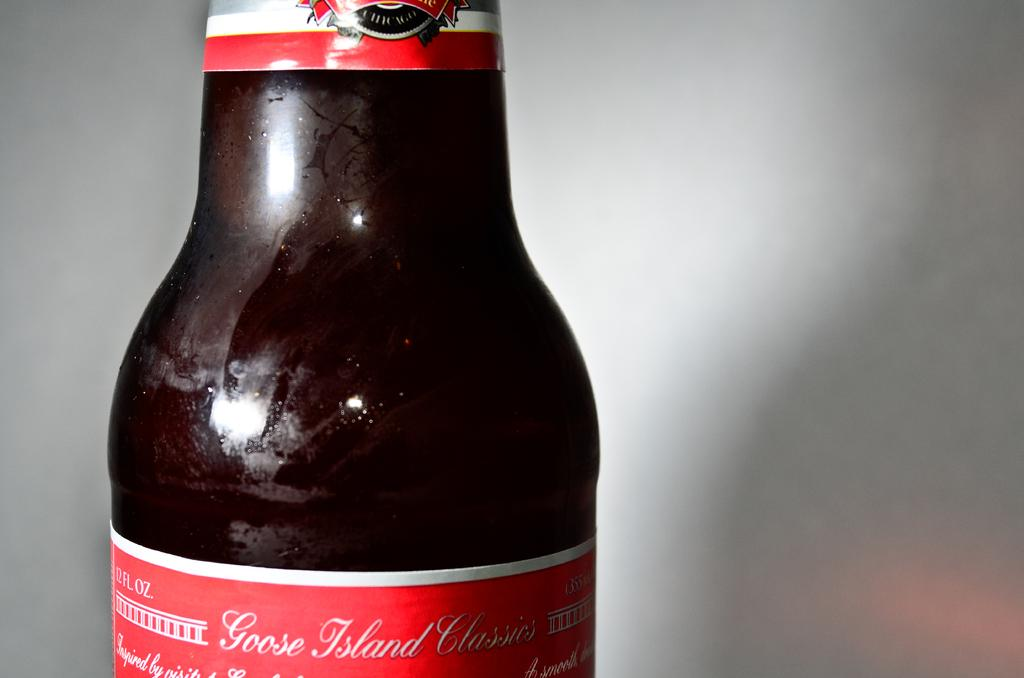<image>
Summarize the visual content of the image. Brown bottle with a red label that says "Goose Island". 